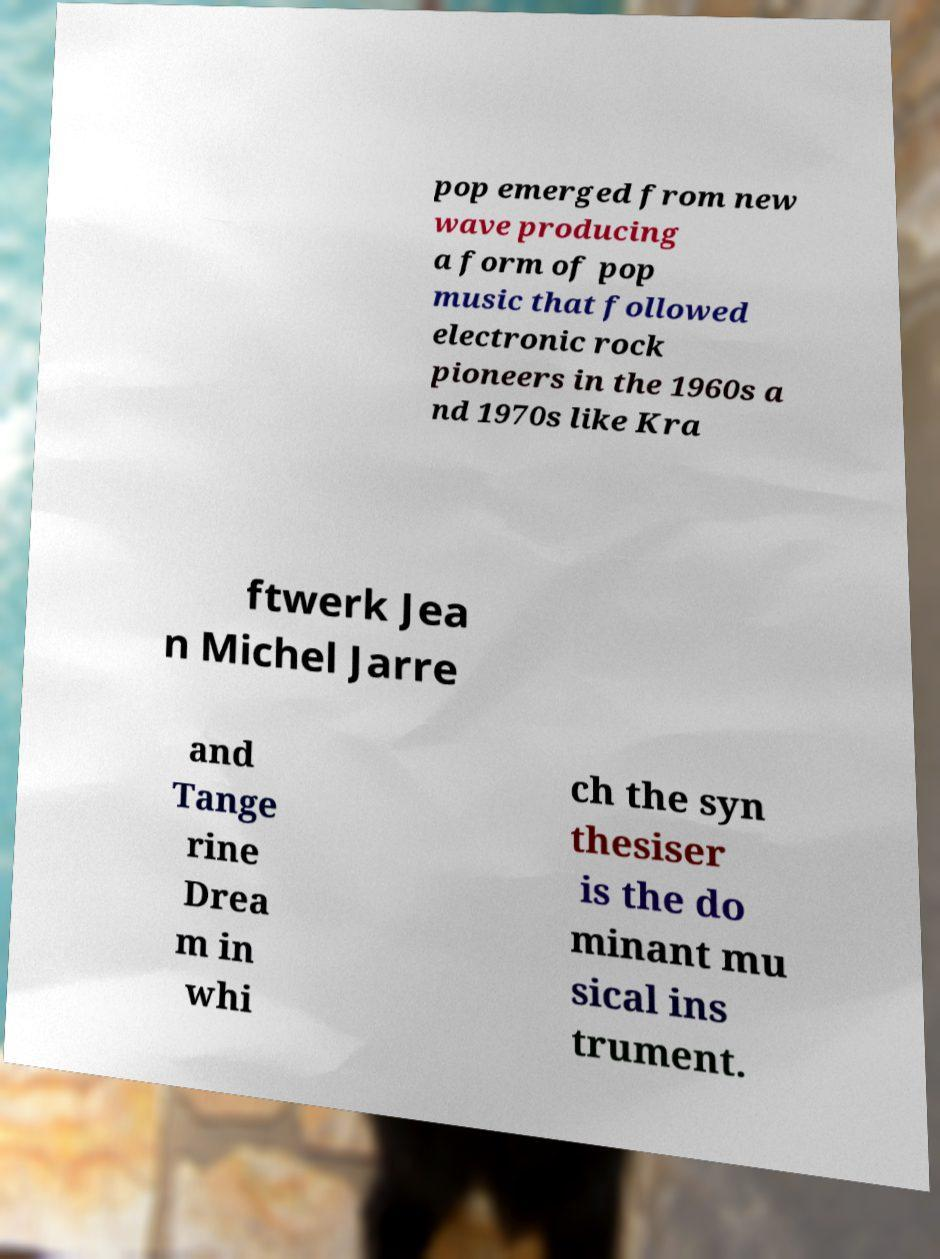Could you assist in decoding the text presented in this image and type it out clearly? pop emerged from new wave producing a form of pop music that followed electronic rock pioneers in the 1960s a nd 1970s like Kra ftwerk Jea n Michel Jarre and Tange rine Drea m in whi ch the syn thesiser is the do minant mu sical ins trument. 